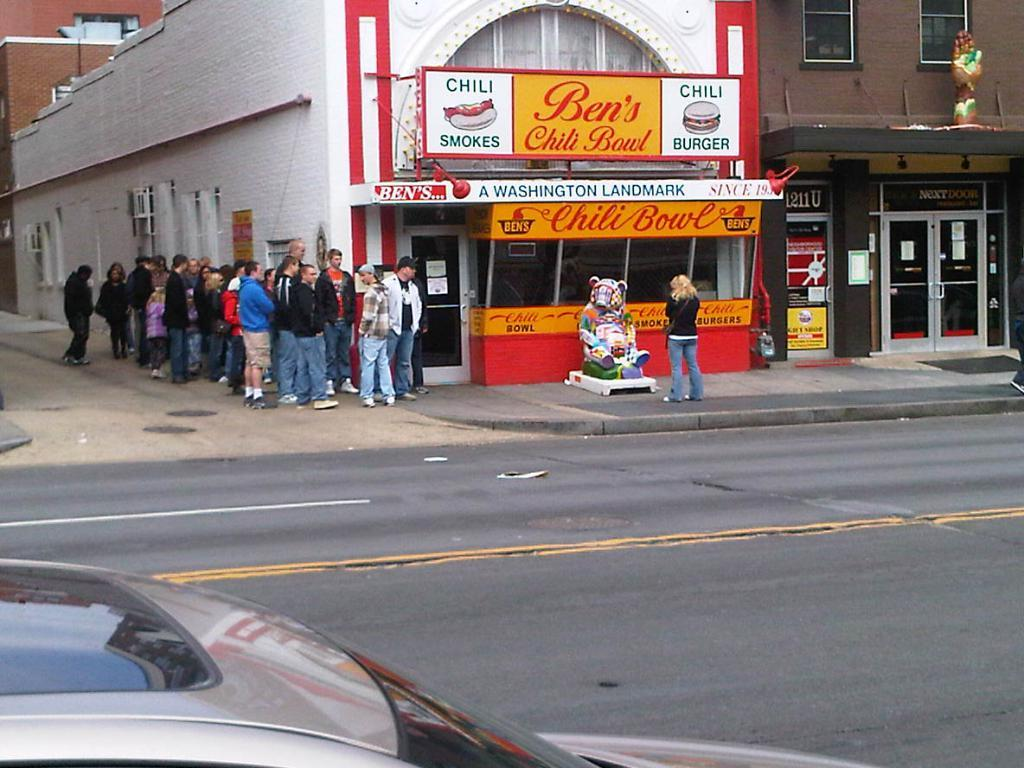<image>
Summarize the visual content of the image. A line of people wait outside of Ben's Chili Stand. 